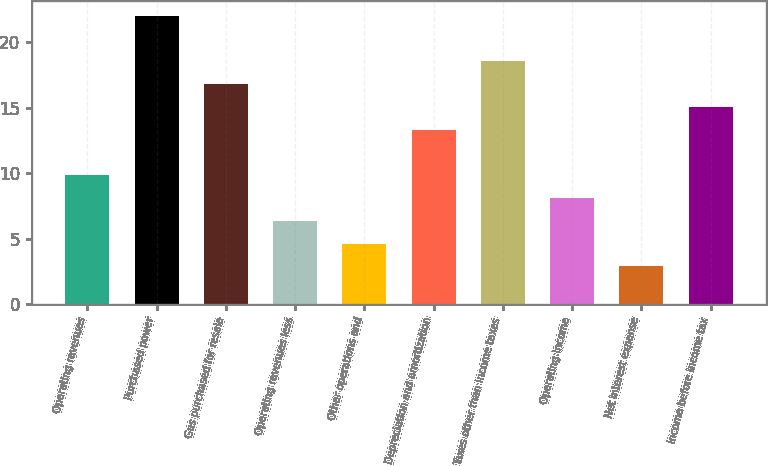Convert chart to OTSL. <chart><loc_0><loc_0><loc_500><loc_500><bar_chart><fcel>Operating revenues<fcel>Purchased power<fcel>Gas purchased for resale<fcel>Operating revenues less<fcel>Other operations and<fcel>Depreciation and amortization<fcel>Taxes other than income taxes<fcel>Operating income<fcel>Net interest expense<fcel>Income before income tax<nl><fcel>9.86<fcel>22.04<fcel>16.82<fcel>6.38<fcel>4.64<fcel>13.34<fcel>18.56<fcel>8.12<fcel>2.9<fcel>15.08<nl></chart> 